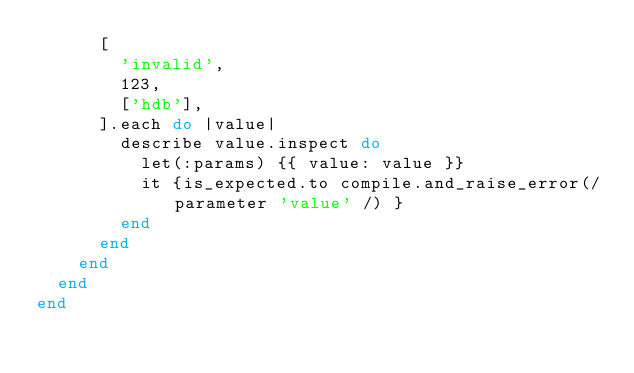Convert code to text. <code><loc_0><loc_0><loc_500><loc_500><_Ruby_>      [
        'invalid',
        123,
        ['hdb'],
      ].each do |value|
        describe value.inspect do
          let(:params) {{ value: value }}
          it {is_expected.to compile.and_raise_error(/parameter 'value' /) }
        end
      end
    end
  end
end
</code> 